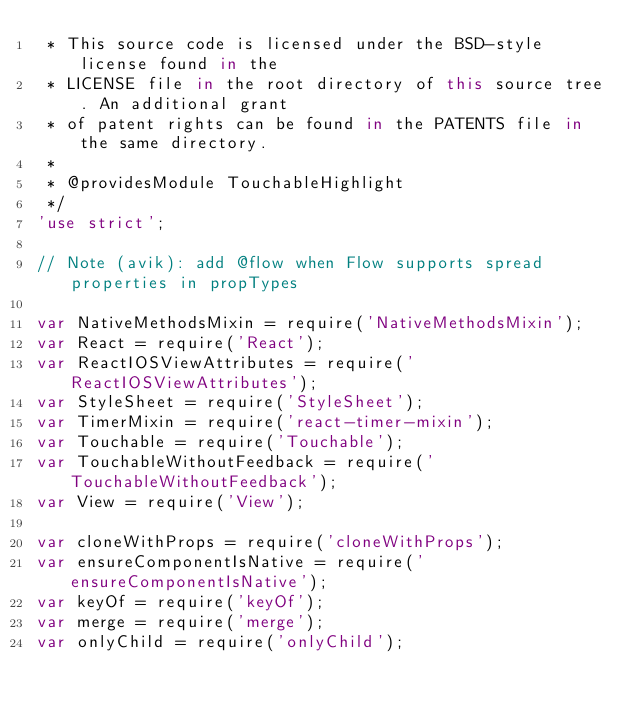<code> <loc_0><loc_0><loc_500><loc_500><_JavaScript_> * This source code is licensed under the BSD-style license found in the
 * LICENSE file in the root directory of this source tree. An additional grant
 * of patent rights can be found in the PATENTS file in the same directory.
 *
 * @providesModule TouchableHighlight
 */
'use strict';

// Note (avik): add @flow when Flow supports spread properties in propTypes

var NativeMethodsMixin = require('NativeMethodsMixin');
var React = require('React');
var ReactIOSViewAttributes = require('ReactIOSViewAttributes');
var StyleSheet = require('StyleSheet');
var TimerMixin = require('react-timer-mixin');
var Touchable = require('Touchable');
var TouchableWithoutFeedback = require('TouchableWithoutFeedback');
var View = require('View');

var cloneWithProps = require('cloneWithProps');
var ensureComponentIsNative = require('ensureComponentIsNative');
var keyOf = require('keyOf');
var merge = require('merge');
var onlyChild = require('onlyChild');
</code> 